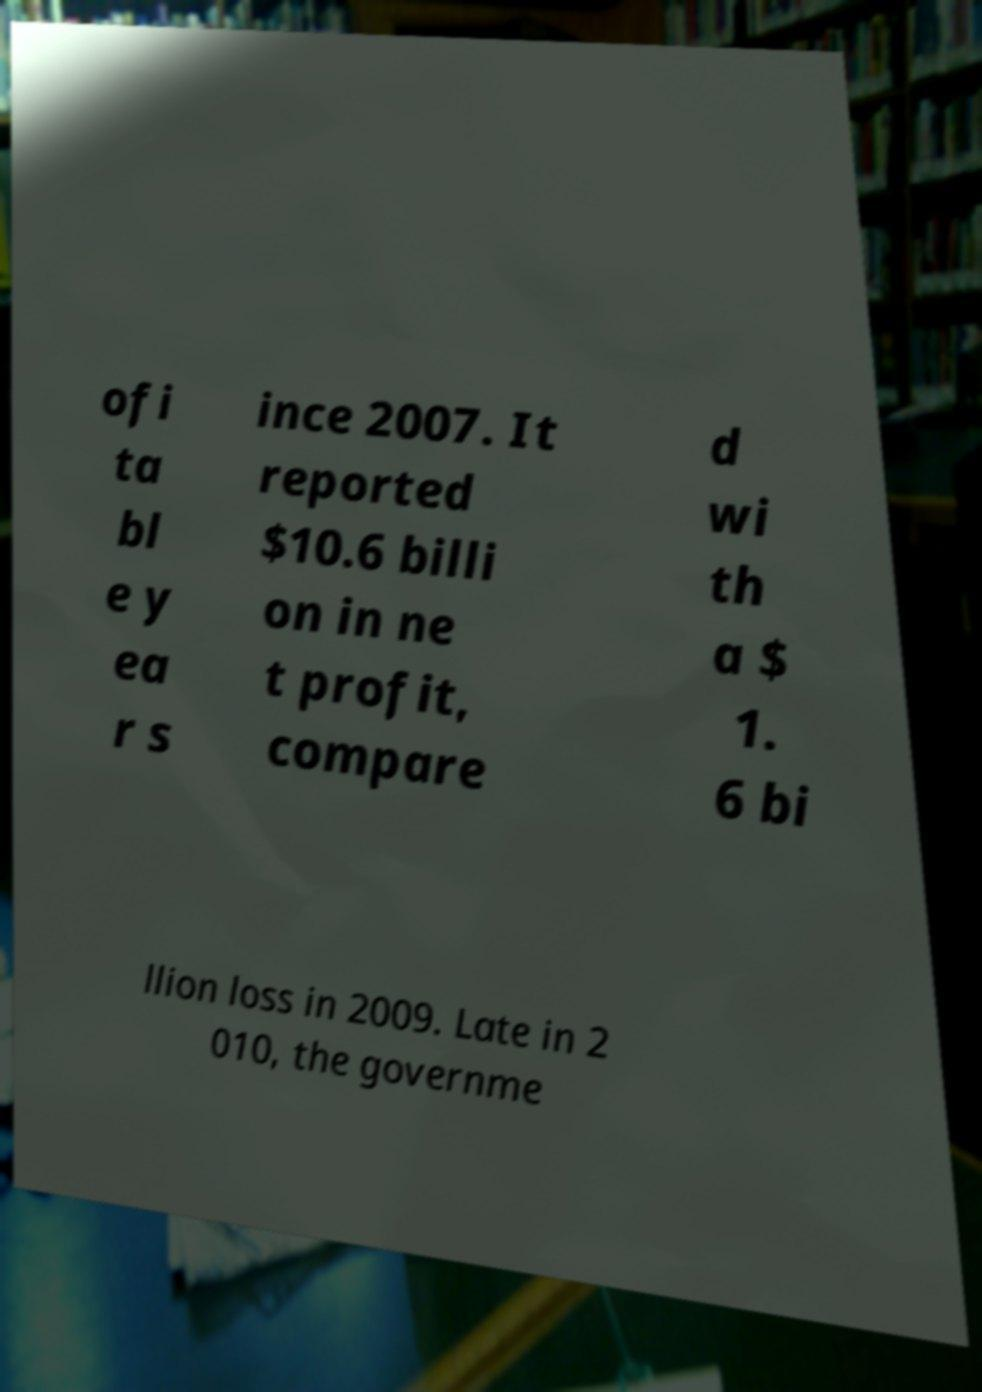What messages or text are displayed in this image? I need them in a readable, typed format. ofi ta bl e y ea r s ince 2007. It reported $10.6 billi on in ne t profit, compare d wi th a $ 1. 6 bi llion loss in 2009. Late in 2 010, the governme 